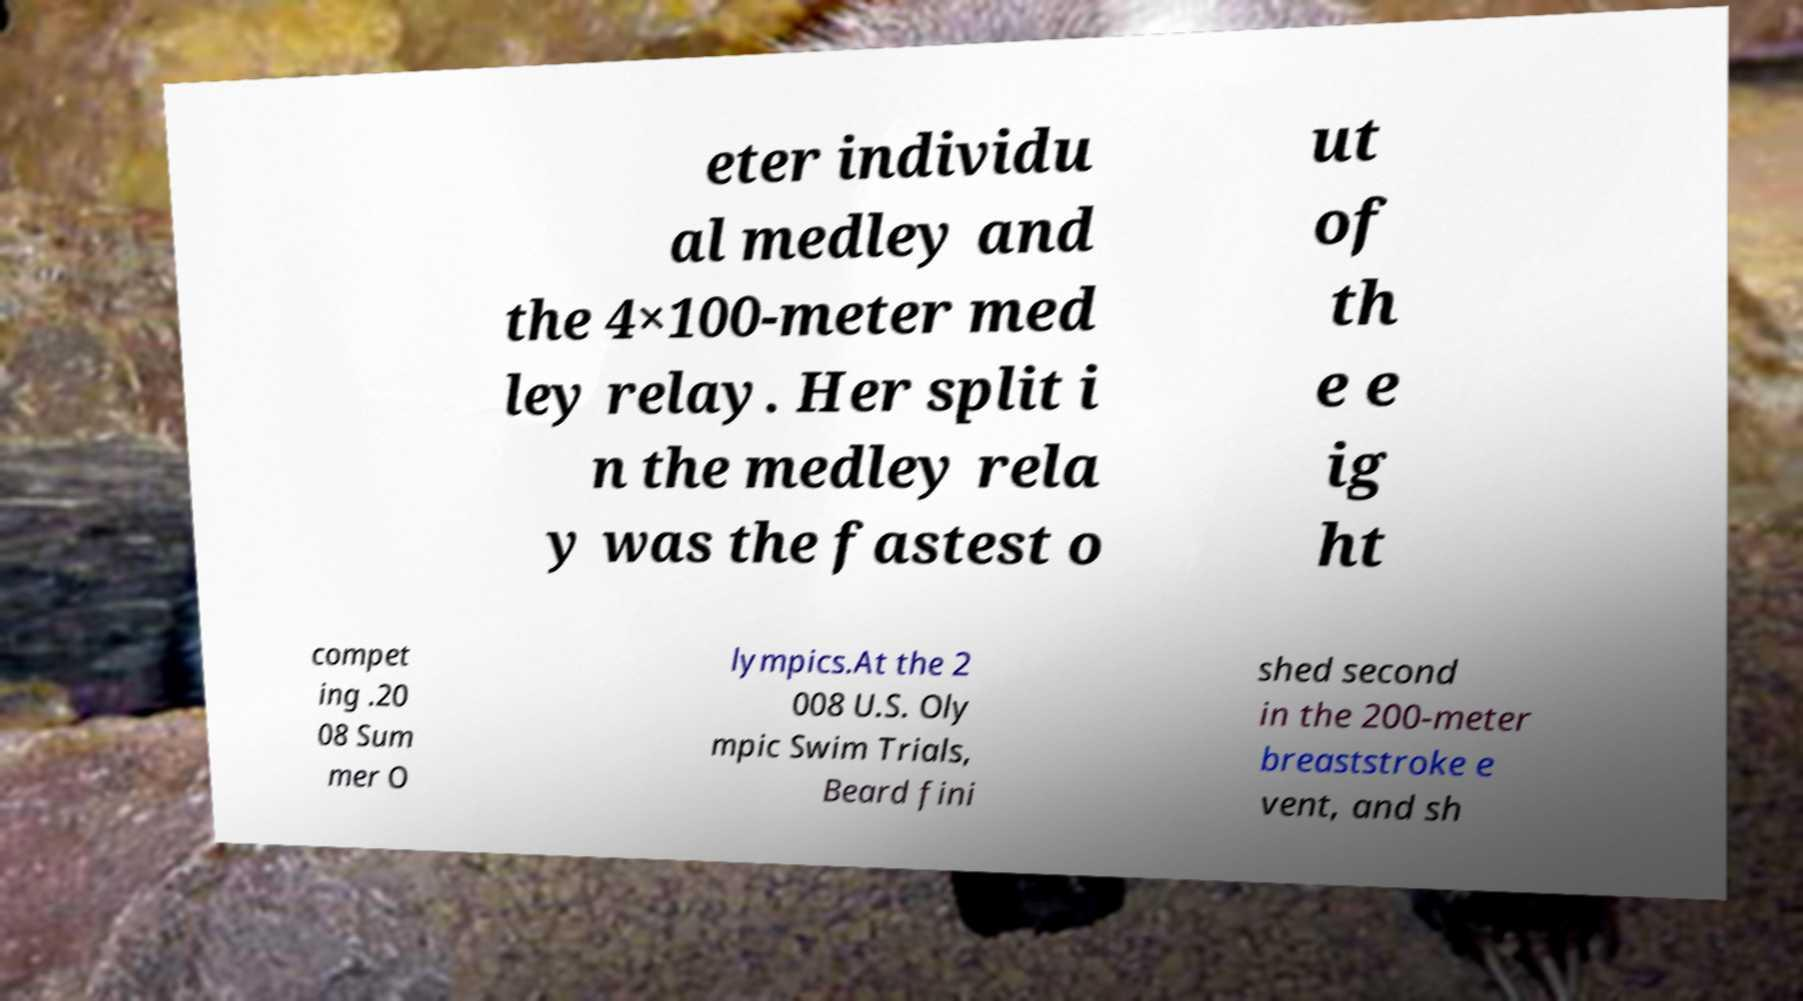What messages or text are displayed in this image? I need them in a readable, typed format. eter individu al medley and the 4×100-meter med ley relay. Her split i n the medley rela y was the fastest o ut of th e e ig ht compet ing .20 08 Sum mer O lympics.At the 2 008 U.S. Oly mpic Swim Trials, Beard fini shed second in the 200-meter breaststroke e vent, and sh 